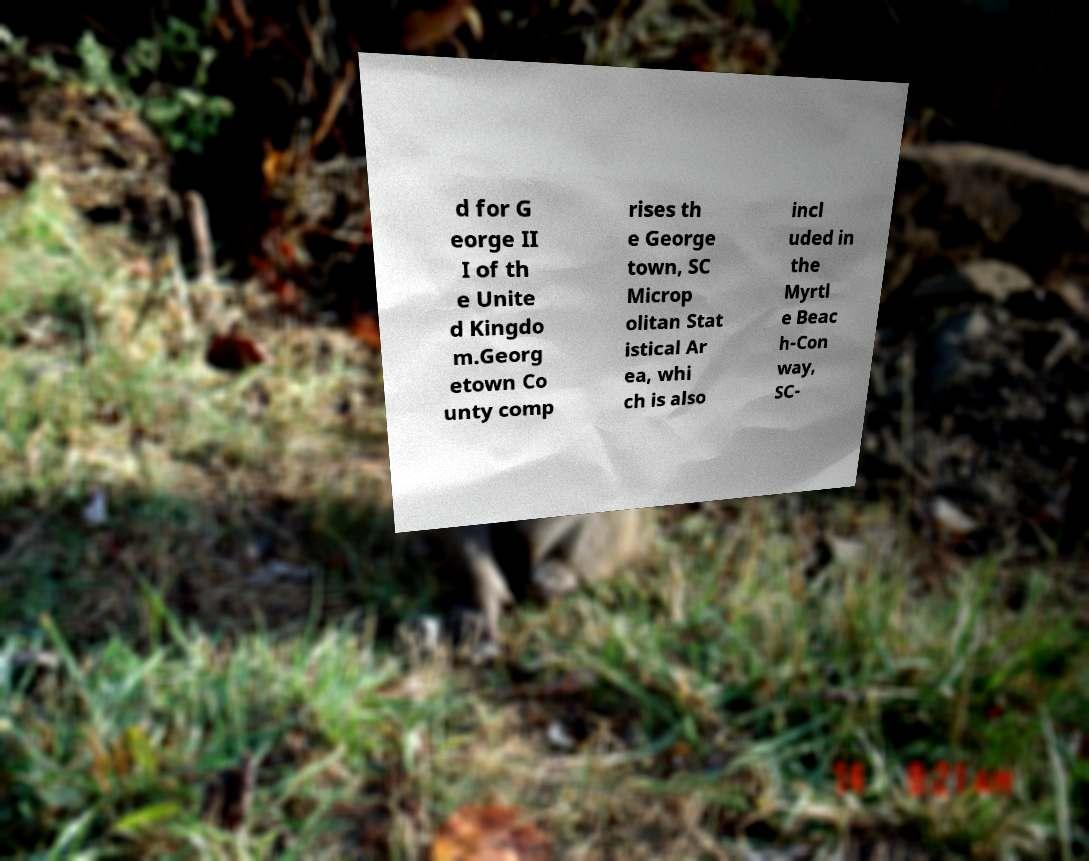What messages or text are displayed in this image? I need them in a readable, typed format. d for G eorge II I of th e Unite d Kingdo m.Georg etown Co unty comp rises th e George town, SC Microp olitan Stat istical Ar ea, whi ch is also incl uded in the Myrtl e Beac h-Con way, SC- 